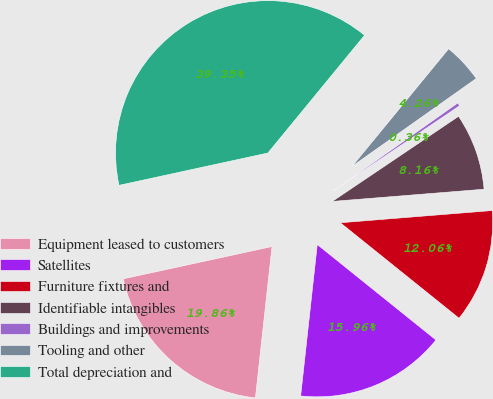Convert chart. <chart><loc_0><loc_0><loc_500><loc_500><pie_chart><fcel>Equipment leased to customers<fcel>Satellites<fcel>Furniture fixtures and<fcel>Identifiable intangibles<fcel>Buildings and improvements<fcel>Tooling and other<fcel>Total depreciation and<nl><fcel>19.86%<fcel>15.96%<fcel>12.06%<fcel>8.16%<fcel>0.36%<fcel>4.26%<fcel>39.35%<nl></chart> 